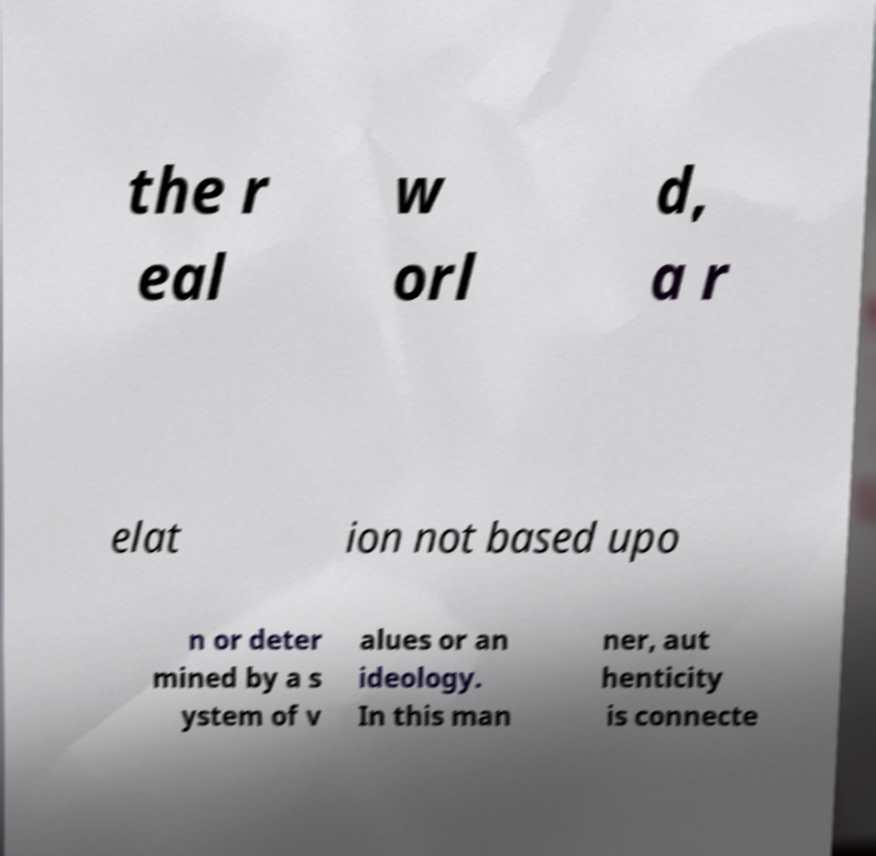Please identify and transcribe the text found in this image. the r eal w orl d, a r elat ion not based upo n or deter mined by a s ystem of v alues or an ideology. In this man ner, aut henticity is connecte 